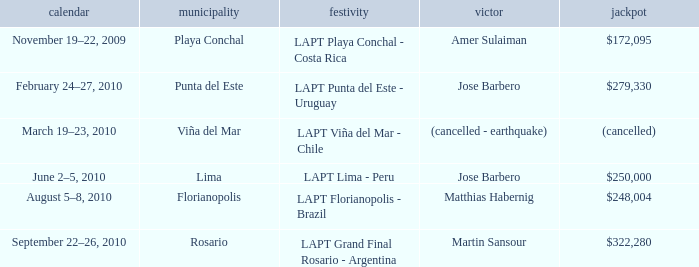What event is in florianopolis? LAPT Florianopolis - Brazil. 